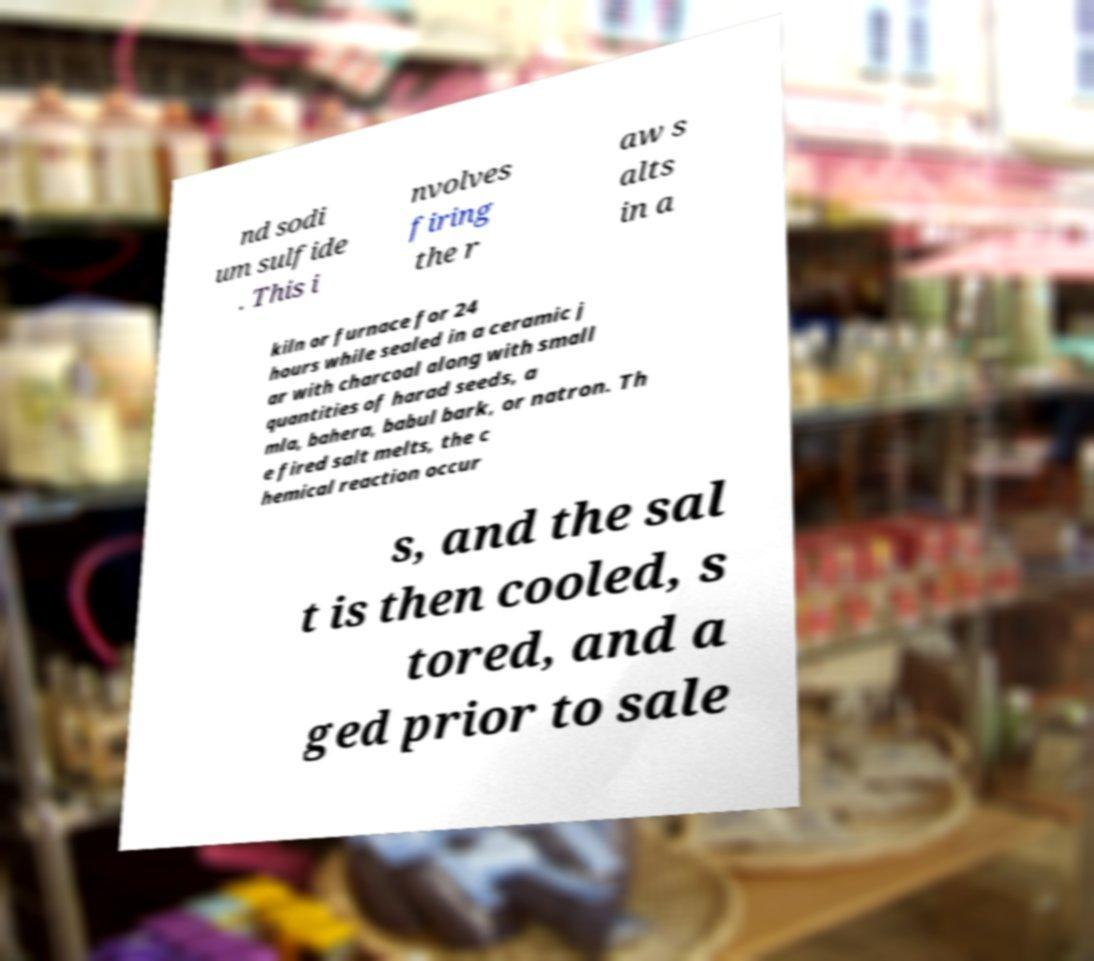Please read and relay the text visible in this image. What does it say? nd sodi um sulfide . This i nvolves firing the r aw s alts in a kiln or furnace for 24 hours while sealed in a ceramic j ar with charcoal along with small quantities of harad seeds, a mla, bahera, babul bark, or natron. Th e fired salt melts, the c hemical reaction occur s, and the sal t is then cooled, s tored, and a ged prior to sale 